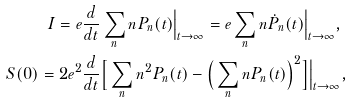<formula> <loc_0><loc_0><loc_500><loc_500>I = e & \frac { d } { d t } \sum _ { n } n P _ { n } ( t ) \Big | _ { t \to \infty } = e \sum _ { n } n \dot { P } _ { n } ( t ) \Big | _ { t \to \infty } , \\ S ( 0 ) = 2 e ^ { 2 } & \frac { d } { d t } \Big [ \sum _ { n } n ^ { 2 } P _ { n } ( t ) - \Big ( \sum _ { n } n P _ { n } ( t ) \Big ) ^ { 2 } \Big ] \Big | _ { t \to \infty } ,</formula> 